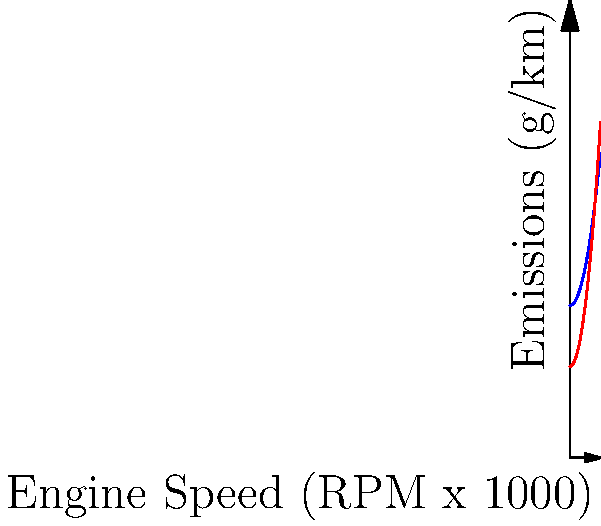Given the emissions curves for two engine designs (A and B) as shown in the graph, which engine is likely to have lower overall emissions across a typical operating range of 2000-8000 RPM? Assume a linear relationship between engine speed and time spent at each speed. To determine which engine has lower overall emissions, we need to compare the areas under the curves for each engine within the given operating range. Here's a step-by-step approach:

1. Identify the functions:
   Engine A: $f_A(x) = 50 + 0.5x^2$
   Engine B: $f_B(x) = 30 + 0.8x^2$

2. Calculate the definite integral for each function from 2 to 8:

   For Engine A:
   $$\int_2^8 (50 + 0.5x^2) dx = [50x + \frac{1}{6}x^3]_2^8$$
   $$= (400 + \frac{512}{6}) - (100 + \frac{8}{6}) = 300 + \frac{504}{6} = 384$$

   For Engine B:
   $$\int_2^8 (30 + 0.8x^2) dx = [30x + \frac{0.8}{3}x^3]_2^8$$
   $$= (240 + \frac{409.6}{3}) - (60 + \frac{6.4}{3}) = 180 + \frac{403.2}{3} = 314.4$$

3. Compare the results:
   Engine A area: 384
   Engine B area: 314.4

4. Interpret the results:
   The lower area under the curve represents lower overall emissions. Engine B has a smaller area, indicating lower overall emissions across the given operating range.
Answer: Engine B 